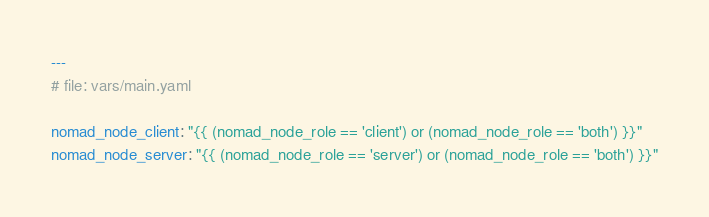Convert code to text. <code><loc_0><loc_0><loc_500><loc_500><_YAML_>---
# file: vars/main.yaml

nomad_node_client: "{{ (nomad_node_role == 'client') or (nomad_node_role == 'both') }}"
nomad_node_server: "{{ (nomad_node_role == 'server') or (nomad_node_role == 'both') }}"
</code> 